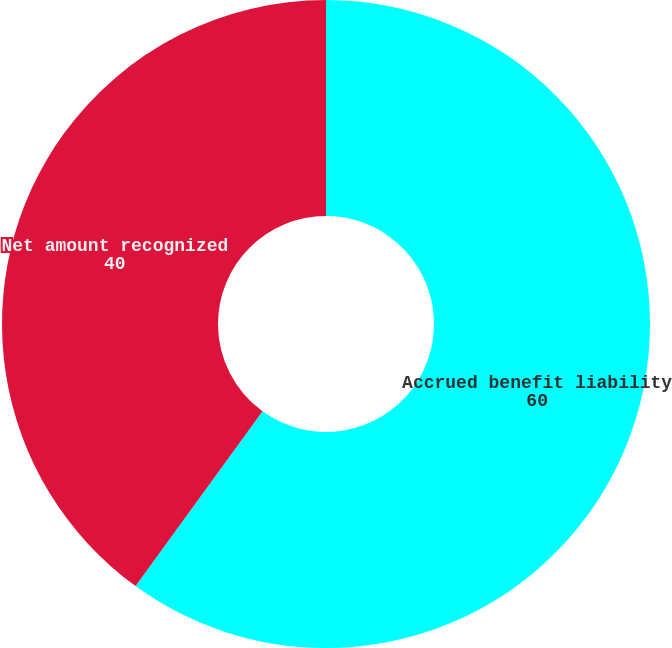Convert chart to OTSL. <chart><loc_0><loc_0><loc_500><loc_500><pie_chart><fcel>Accrued benefit liability<fcel>Net amount recognized<nl><fcel>60.0%<fcel>40.0%<nl></chart> 